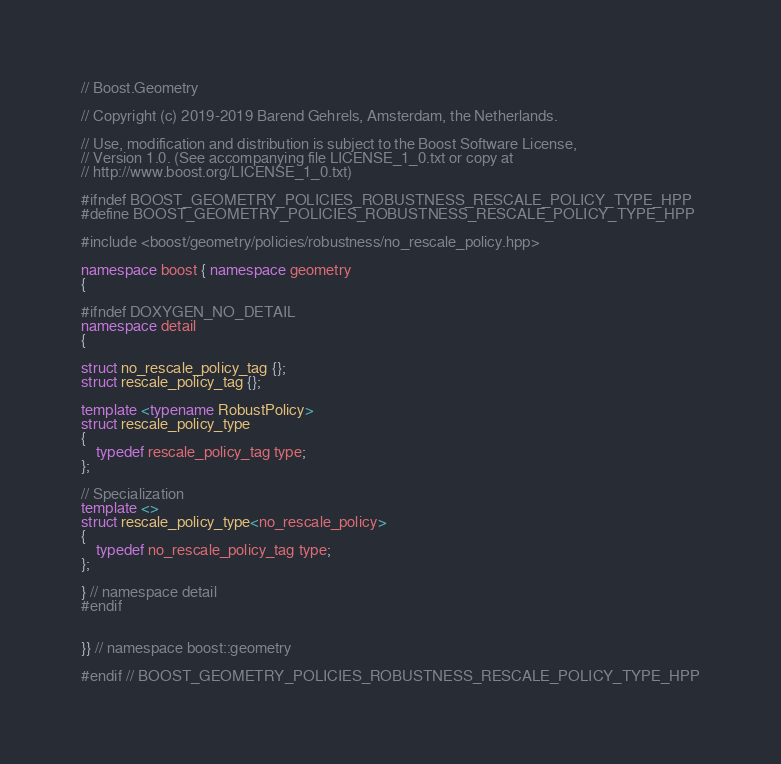Convert code to text. <code><loc_0><loc_0><loc_500><loc_500><_C++_>// Boost.Geometry

// Copyright (c) 2019-2019 Barend Gehrels, Amsterdam, the Netherlands.

// Use, modification and distribution is subject to the Boost Software License,
// Version 1.0. (See accompanying file LICENSE_1_0.txt or copy at
// http://www.boost.org/LICENSE_1_0.txt)

#ifndef BOOST_GEOMETRY_POLICIES_ROBUSTNESS_RESCALE_POLICY_TYPE_HPP
#define BOOST_GEOMETRY_POLICIES_ROBUSTNESS_RESCALE_POLICY_TYPE_HPP

#include <boost/geometry/policies/robustness/no_rescale_policy.hpp>

namespace boost { namespace geometry
{

#ifndef DOXYGEN_NO_DETAIL
namespace detail
{

struct no_rescale_policy_tag {};
struct rescale_policy_tag {};

template <typename RobustPolicy>
struct rescale_policy_type
{
    typedef rescale_policy_tag type;
};

// Specialization
template <>
struct rescale_policy_type<no_rescale_policy>
{
    typedef no_rescale_policy_tag type;
};

} // namespace detail
#endif


}} // namespace boost::geometry

#endif // BOOST_GEOMETRY_POLICIES_ROBUSTNESS_RESCALE_POLICY_TYPE_HPP
</code> 